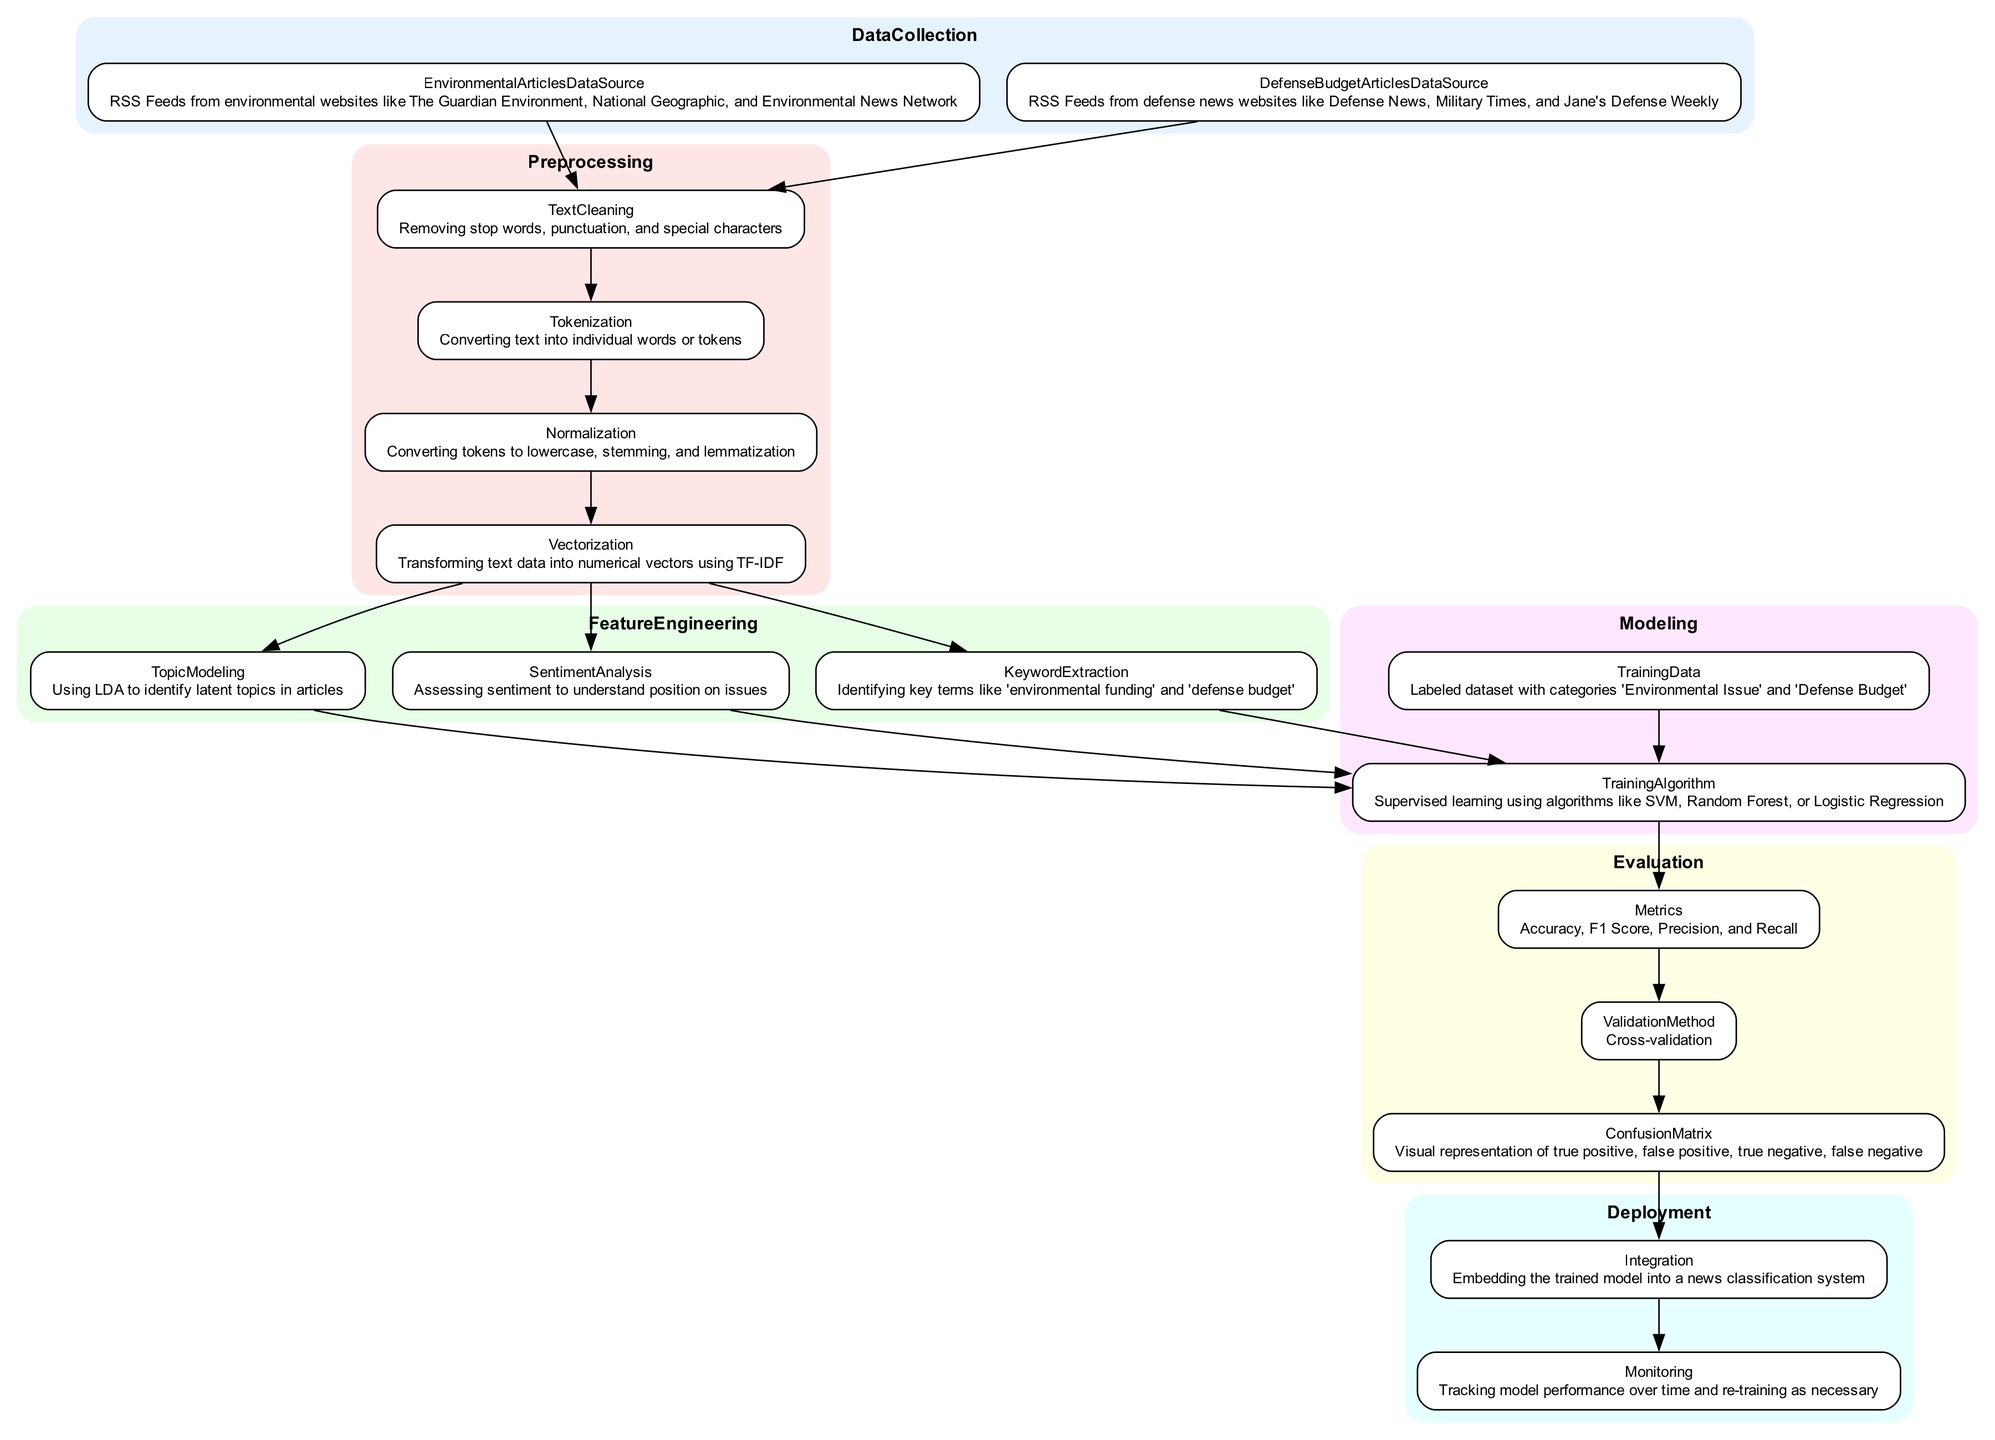What are the data sources for Environmental Articles? The diagram states that the data sources for Environmental Articles are RSS Feeds from environmental websites like The Guardian Environment, National Geographic, and Environmental News Network.
Answer: RSS Feeds from environmental websites like The Guardian Environment, National Geographic, and Environmental News Network How many nodes are present in the Evaluation section? The Evaluation section contains four nodes: Metrics, Validation Method, Confusion Matrix, and the one connecting to Deployment Integration. Therefore, there are three distinct nodes shown in this section (other points like 'Deployment_Monitoring' are a continuation from the last).
Answer: 3 What is the first step in Preprocessing? The first step in the Preprocessing section is Text Cleaning, which involves removing stop words, punctuation, and special characters. This is indicated as the first node in the Preprocessing subgraph.
Answer: Text Cleaning Which step directly follows Vectorization? The step that directly follows Vectorization is Topic Modeling, as the edge from Vectorization points directly to the Topic Modeling node in the diagram.
Answer: Topic Modeling Which topic does the Training Algorithm focus on? The diagram indicates that the Training Algorithm focuses on supervised learning using algorithms like SVM, Random Forest, or Logistic Regression, which are grouped under Modeling.
Answer: Supervised Learning What's the output measure used for Evaluation? The output measures used for Evaluation include Accuracy, F1 Score, Precision, and Recall. This information is clearly labeled in the Metrics node of the Evaluation section.
Answer: Accuracy, F1 Score, Precision, and Recall What connections are present between Preprocessing and Feature Engineering? The connections present are that Vectorization leads to Topic Modeling, Sentiment Analysis, and Keyword Extraction in the Feature Engineering step. Each of these three nodes is reached directly after the Vectorization node in the diagram.
Answer: Vectorization to Topic Modeling, Sentiment Analysis, Keyword Extraction What is the purpose of Monitoring in the Deployment section? The purpose of Monitoring in the Deployment section is to track model performance over time and re-train as necessary, as specified in the Monitoring node.
Answer: Track model performance over time and re-train as necessary 